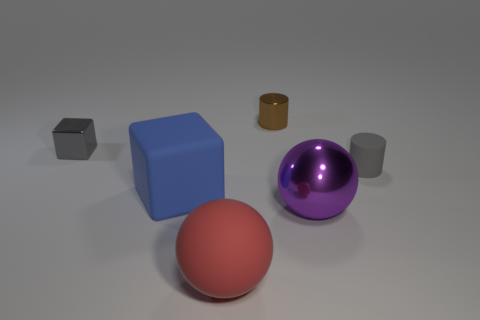Add 3 large purple cylinders. How many objects exist? 9 Subtract all spheres. How many objects are left? 4 Subtract all tiny brown shiny spheres. Subtract all red balls. How many objects are left? 5 Add 1 tiny brown cylinders. How many tiny brown cylinders are left? 2 Add 2 large purple balls. How many large purple balls exist? 3 Subtract 0 purple cylinders. How many objects are left? 6 